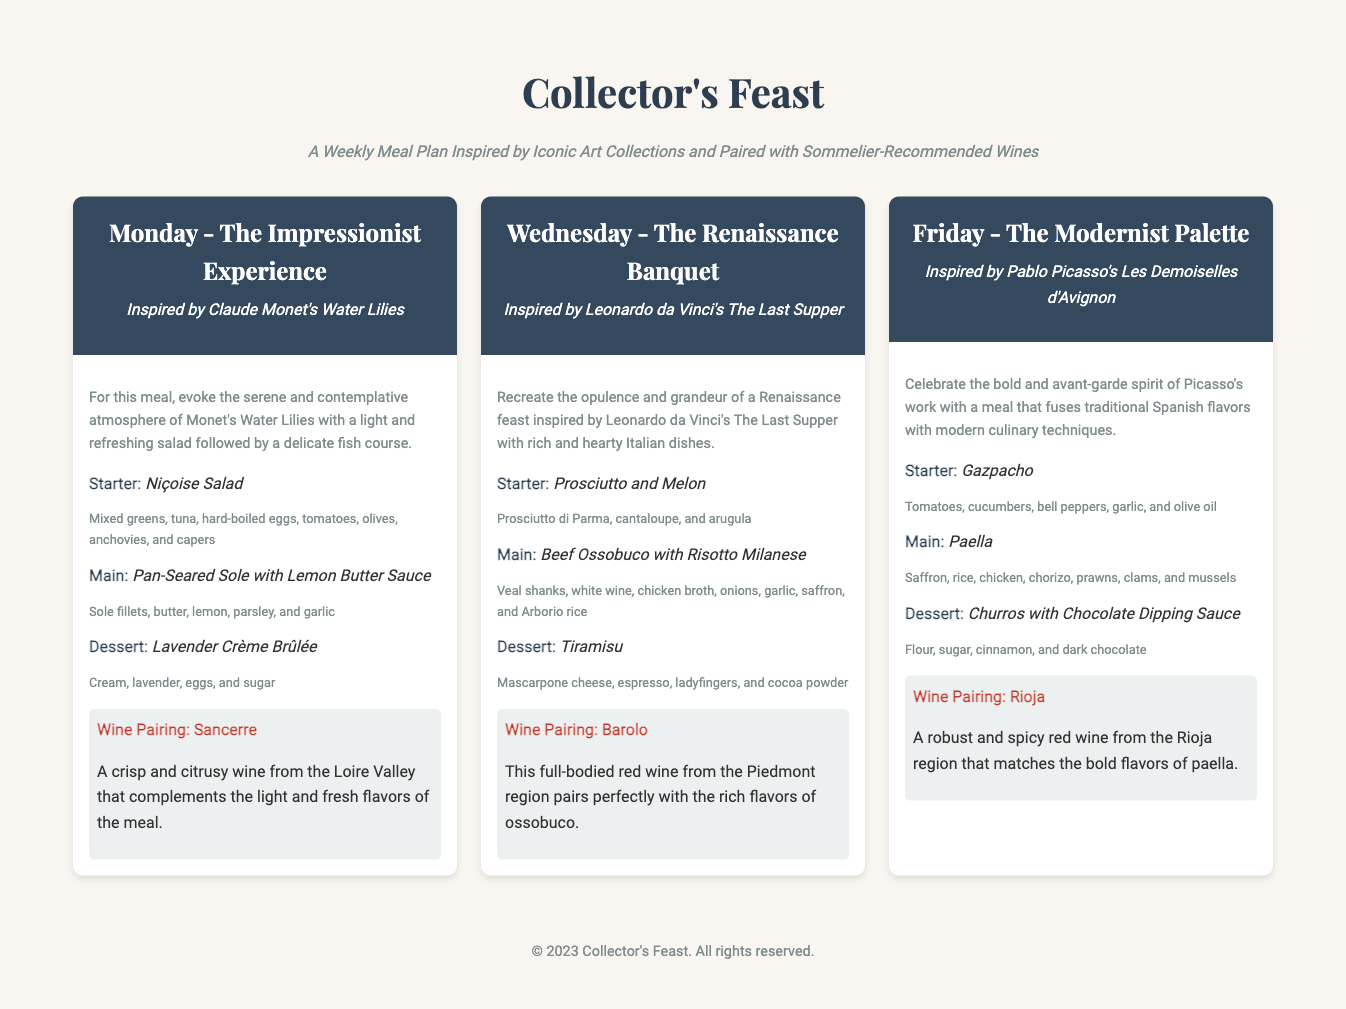What is the title of the meal plan? The title of the meal plan is displayed prominently at the top of the document.
Answer: Collector's Feast Which artist inspired the Monday meal? The artwork associated with the Monday meal plan is mentioned clearly under the day heading.
Answer: Claude Monet What is the main dish for Wednesday? The main dish is specified in the menu section for Wednesday's meal.
Answer: Beef Ossobuco with Risotto Milanese What type of wine is paired with the Friday meal? The wine pairing is described in the wine pairing section for Friday's meal.
Answer: Rioja How many courses are included in the Monday meal? The structure of the meal describes the number of courses listed for Monday.
Answer: Three courses What key ingredient is in the Niçoise Salad? The Niçoise Salad description includes specific ingredients, one of which is highlighted.
Answer: Tuna Which meal focuses on modern culinary techniques? The descriptions provide insights on which day's meal showcases modern techniques.
Answer: Friday What is the dessert for the Renaissance Banquet? The dessert is clearly stated in the menu part of the Wednesday meal.
Answer: Tiramisu What vegetable is included in the Gazpacho? The ingredients of the Gazpacho are explicitly listed, including this vegetable.
Answer: Cucumbers 